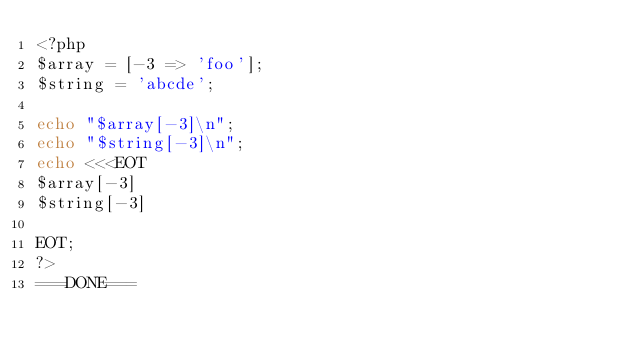<code> <loc_0><loc_0><loc_500><loc_500><_PHP_><?php
$array = [-3 => 'foo'];
$string = 'abcde';

echo "$array[-3]\n";
echo "$string[-3]\n";
echo <<<EOT
$array[-3]
$string[-3]

EOT;
?>
===DONE===
</code> 